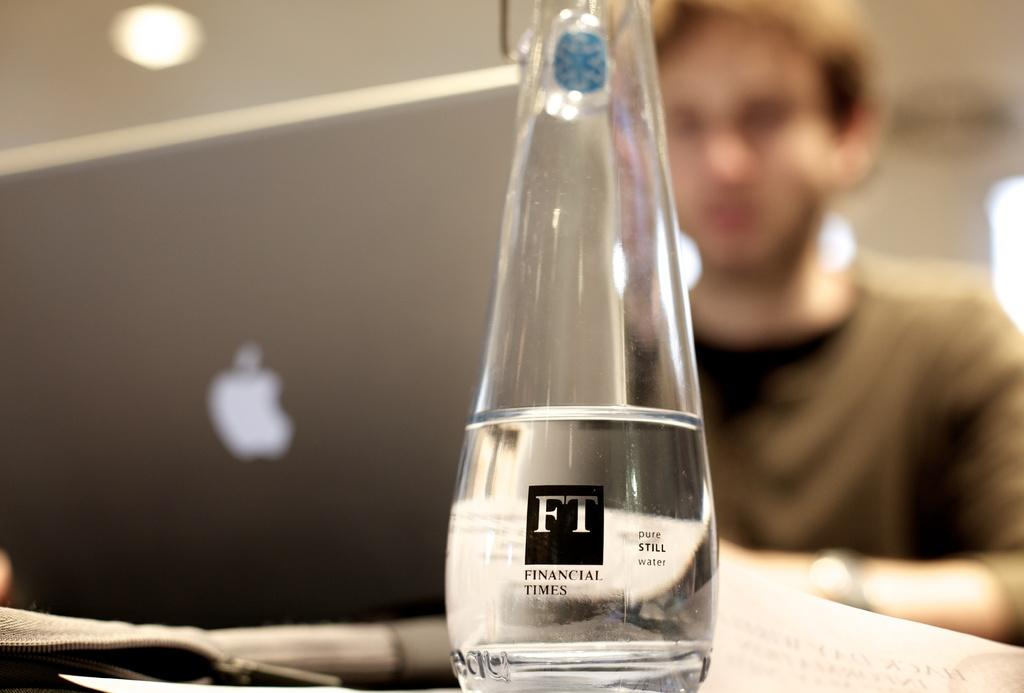<image>
Present a compact description of the photo's key features. A glass beaker with liquid on it saying financial times 